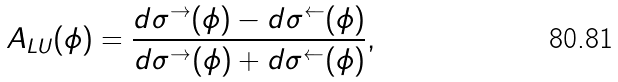Convert formula to latex. <formula><loc_0><loc_0><loc_500><loc_500>A _ { L U } ( \phi ) = \frac { d \sigma ^ { \rightarrow } ( \phi ) - d \sigma ^ { \leftarrow } ( \phi ) } { d \sigma ^ { \rightarrow } ( \phi ) + d \sigma ^ { \leftarrow } ( \phi ) } ,</formula> 